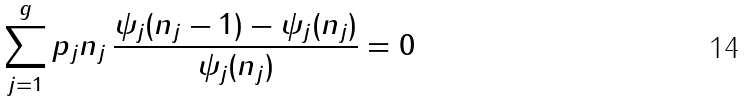<formula> <loc_0><loc_0><loc_500><loc_500>\sum _ { j = 1 } ^ { g } p _ { j } n _ { j } \, \frac { \psi _ { j } ( n _ { j } - 1 ) - \psi _ { j } ( n _ { j } ) } { \psi _ { j } ( n _ { j } ) } = 0</formula> 